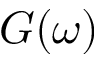Convert formula to latex. <formula><loc_0><loc_0><loc_500><loc_500>G ( \omega )</formula> 